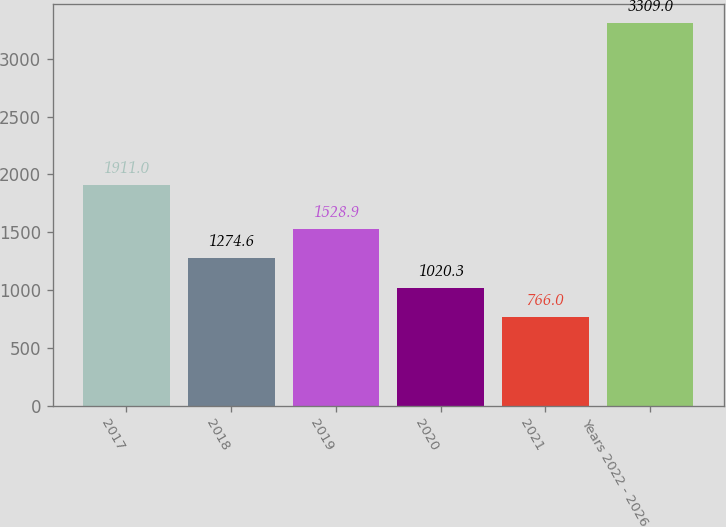Convert chart. <chart><loc_0><loc_0><loc_500><loc_500><bar_chart><fcel>2017<fcel>2018<fcel>2019<fcel>2020<fcel>2021<fcel>Years 2022 - 2026<nl><fcel>1911<fcel>1274.6<fcel>1528.9<fcel>1020.3<fcel>766<fcel>3309<nl></chart> 